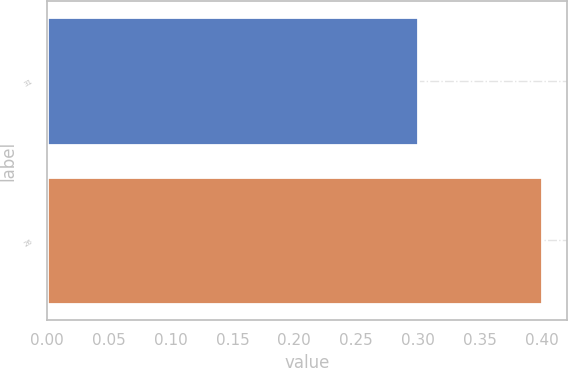Convert chart. <chart><loc_0><loc_0><loc_500><loc_500><bar_chart><fcel>31<fcel>26<nl><fcel>0.3<fcel>0.4<nl></chart> 